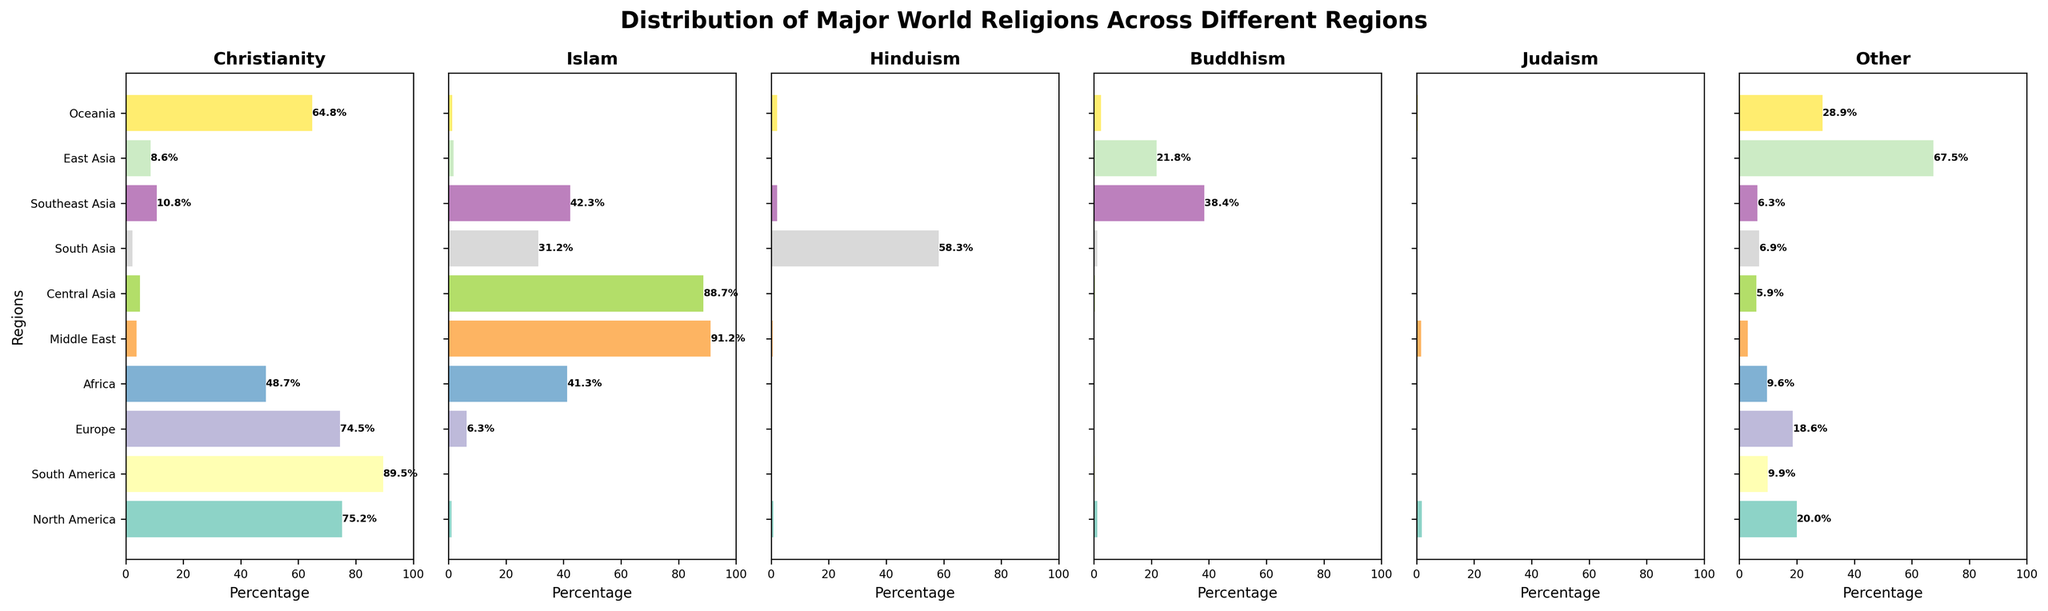Which region has the highest percentage of Buddhism? To find the highest percentage of Buddhism, look at the bar with the longest length in the Buddhism subplot. Southeast Asia has the longest bar in this subplot.
Answer: Southeast Asia Compare the percentage of Christianity in North America and South America. Which one is higher? Examining the Christianity subplot, look at the lengths of the bars for North America and South America. The bar for South America is longer.
Answer: South America What is the sum of the percentages of Hinduism and Buddhism in South Asia? Look at the Hinduism and Buddhism subplots and locate the bars for South Asia. Sum the two values: 58.3 (Hinduism) + 1.2 (Buddhism) = 59.5.
Answer: 59.5 Which region has the smallest percentage of Judaism? Identify the region with the shortest bar in the Judaism subplot. Multiple regions (Africa, Central Asia, South Asia, Southeast Asia) have a bar length of 0.1, which is the smallest.
Answer: Africa, Central Asia, South Asia, Southeast Asia Is the percentage of Islam in Central Asia greater than or less than in the Middle East? Compare the lengths of the bars for Islam in Central Asia and the Middle East. The bar for the Middle East is longer.
Answer: Less than Which region has the longest bar in the 'Other' subplot? To find the longest bar in the 'Other' subplot, look for the region with the highest percentage. East Asia has the longest bar.
Answer: East Asia What is the average percentage of Christianity across all regions? Add the percentages of Christianity for all regions and divide by the number of regions: (75.2 + 89.5 + 74.5 + 48.7 + 3.7 + 4.9 + 2.3 + 10.8 + 8.6 + 64.8) / 10 = 38.3.
Answer: 38.3 Compare the percentage of Islam in Africa and Southeast Asia. Which region has a higher percentage? Look at the Islam subplot and compare the lengths of the bars for Africa and Southeast Asia. The bar for Southeast Asia is longer.
Answer: Southeast Asia How does the percentage of Buddhism in East Asia compare to that in Southeast Asia? Examine the Buddhism subplot and compare the lengths of the bars for East Asia and Southeast Asia. The bar for Southeast Asia is longer.
Answer: Lower in East Asia What is the percent difference of Islam between North America and South Asia? Calculate the percent difference: 31.2 (South Asia) - 1.1 (North America) = 30.1.
Answer: 30.1 